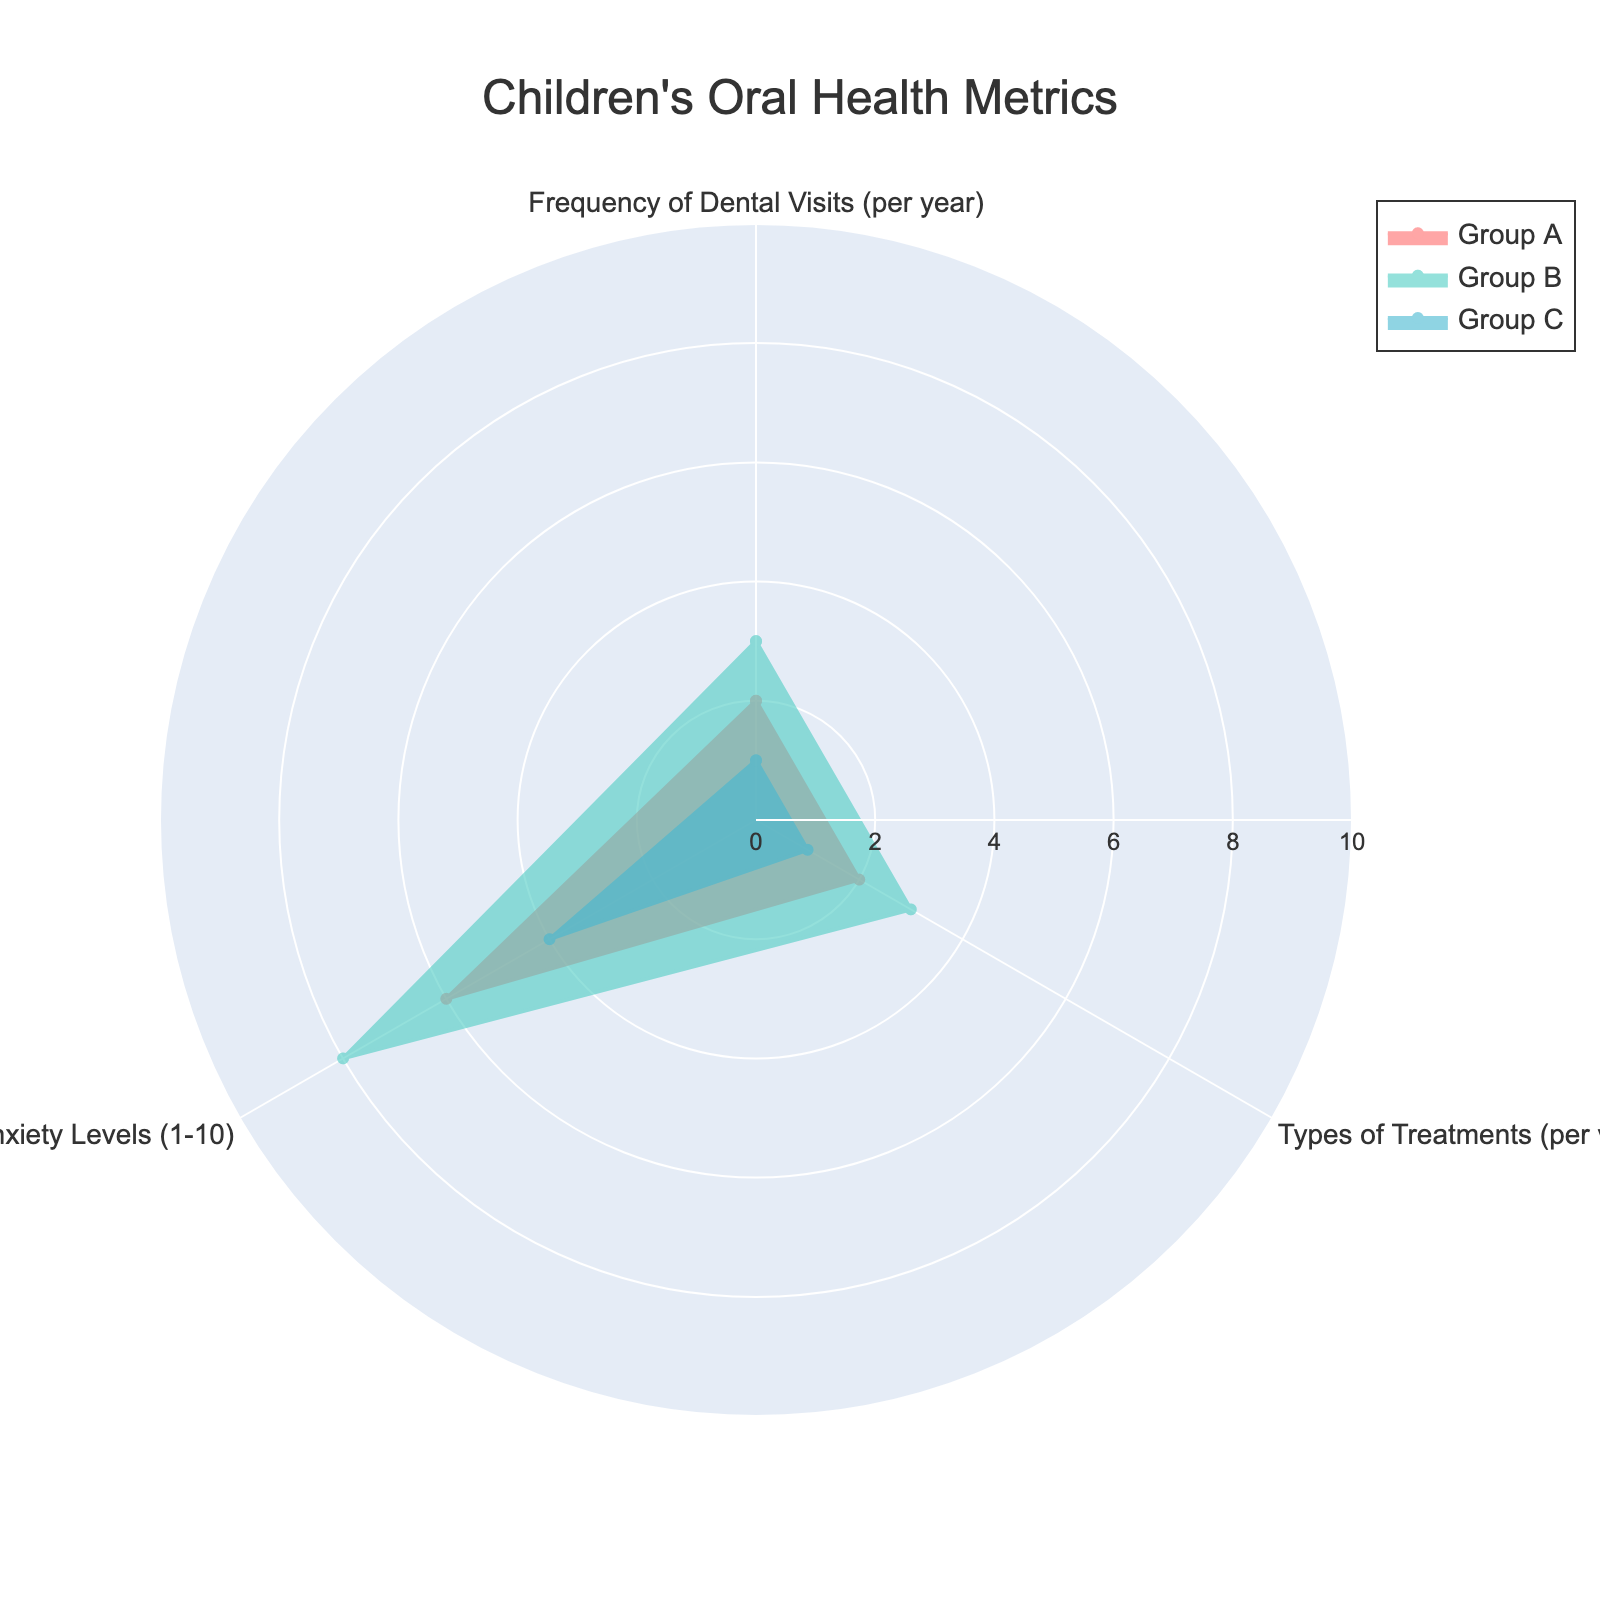What is the title of the radar chart? The title is usually displayed at the top of the chart. The chart shows "Children's Oral Health Metrics".
Answer: Children's Oral Health Metrics Which group has the highest number of dental visits per year? By inspecting the radial values for "Frequency of Dental Visits (per year)", Group B has the highest value.
Answer: Group B How many types of treatments does Group D typically receive per visit? From the radial values for "Types of Treatments (per visit)", Group D has 4 types of treatments.
Answer: 4 Which group shows the lowest parental anxiety levels? By looking at the values for "Parental Anxiety Levels", Group C has the lowest value (4).
Answer: Group C Which group appears to have the most balanced values across all metrics? Comparing the radial plots for each group, Group A appears to have similar values for all metrics.
Answer: Group A What is the average value of the "Types of Treatments (per visit)" for Groups A, B, and C? Adding the values for "Types of Treatments (per visit)" for Groups A (2), B (3), and C (1) and dividing by the number of groups (3), we get (2+3+1)/3 = 2.
Answer: 2 Is the parental anxiety level of Group B higher or lower than Group D? Comparing the radial values for "Parental Anxiety Levels", Group B has a value of 8 while Group D has a value of 7.
Answer: Higher What is the total number of types of treatments across all groups in the chart? Adding up "Types of Treatments (per visit)" for Groups A (2), B (3), and C (1): 2+3+1 = 6.
Answer: 6 Which group has the largest spread between the highest and lowest values? Group D has a range from 2 (Frequency of Dental Visits) to 7 (Parental Anxiety Levels) with a difference of 7-2 = 5. Groups A, B, and C have smaller spreads.
Answer: Group D 